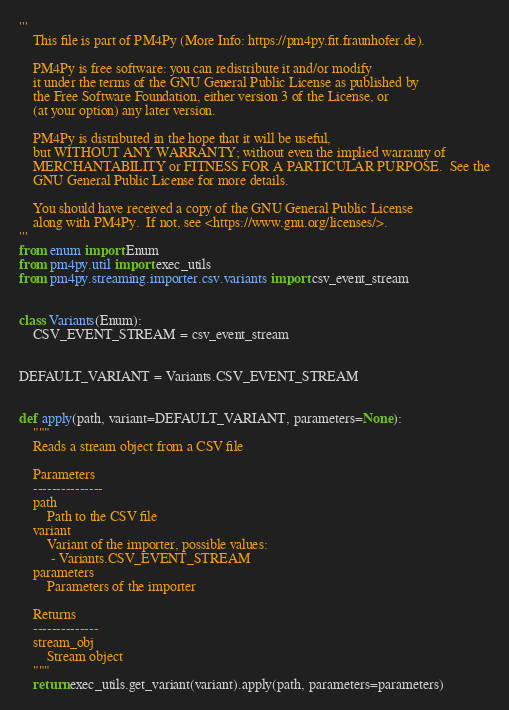Convert code to text. <code><loc_0><loc_0><loc_500><loc_500><_Python_>'''
    This file is part of PM4Py (More Info: https://pm4py.fit.fraunhofer.de).

    PM4Py is free software: you can redistribute it and/or modify
    it under the terms of the GNU General Public License as published by
    the Free Software Foundation, either version 3 of the License, or
    (at your option) any later version.

    PM4Py is distributed in the hope that it will be useful,
    but WITHOUT ANY WARRANTY; without even the implied warranty of
    MERCHANTABILITY or FITNESS FOR A PARTICULAR PURPOSE.  See the
    GNU General Public License for more details.

    You should have received a copy of the GNU General Public License
    along with PM4Py.  If not, see <https://www.gnu.org/licenses/>.
'''
from enum import Enum
from pm4py.util import exec_utils
from pm4py.streaming.importer.csv.variants import csv_event_stream


class Variants(Enum):
    CSV_EVENT_STREAM = csv_event_stream


DEFAULT_VARIANT = Variants.CSV_EVENT_STREAM


def apply(path, variant=DEFAULT_VARIANT, parameters=None):
    """
    Reads a stream object from a CSV file

    Parameters
    ---------------
    path
        Path to the CSV file
    variant
        Variant of the importer, possible values:
         - Variants.CSV_EVENT_STREAM
    parameters
        Parameters of the importer

    Returns
    --------------
    stream_obj
        Stream object
    """
    return exec_utils.get_variant(variant).apply(path, parameters=parameters)
</code> 